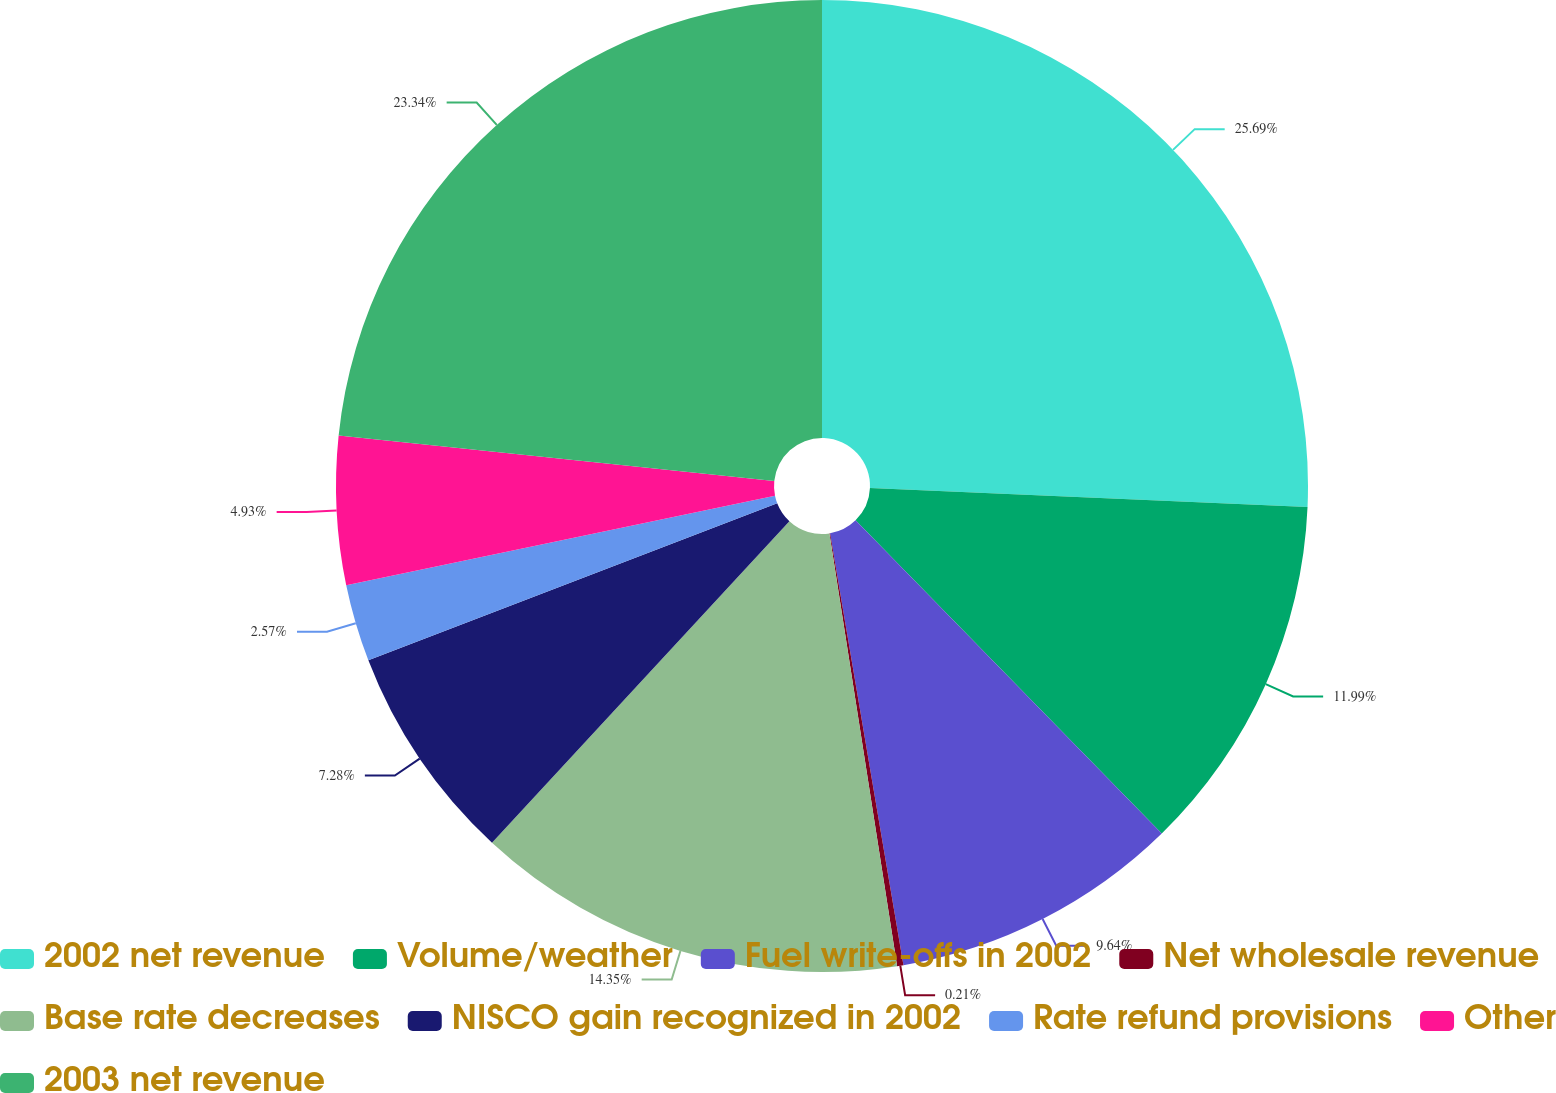Convert chart. <chart><loc_0><loc_0><loc_500><loc_500><pie_chart><fcel>2002 net revenue<fcel>Volume/weather<fcel>Fuel write-offs in 2002<fcel>Net wholesale revenue<fcel>Base rate decreases<fcel>NISCO gain recognized in 2002<fcel>Rate refund provisions<fcel>Other<fcel>2003 net revenue<nl><fcel>25.69%<fcel>11.99%<fcel>9.64%<fcel>0.21%<fcel>14.35%<fcel>7.28%<fcel>2.57%<fcel>4.93%<fcel>23.34%<nl></chart> 